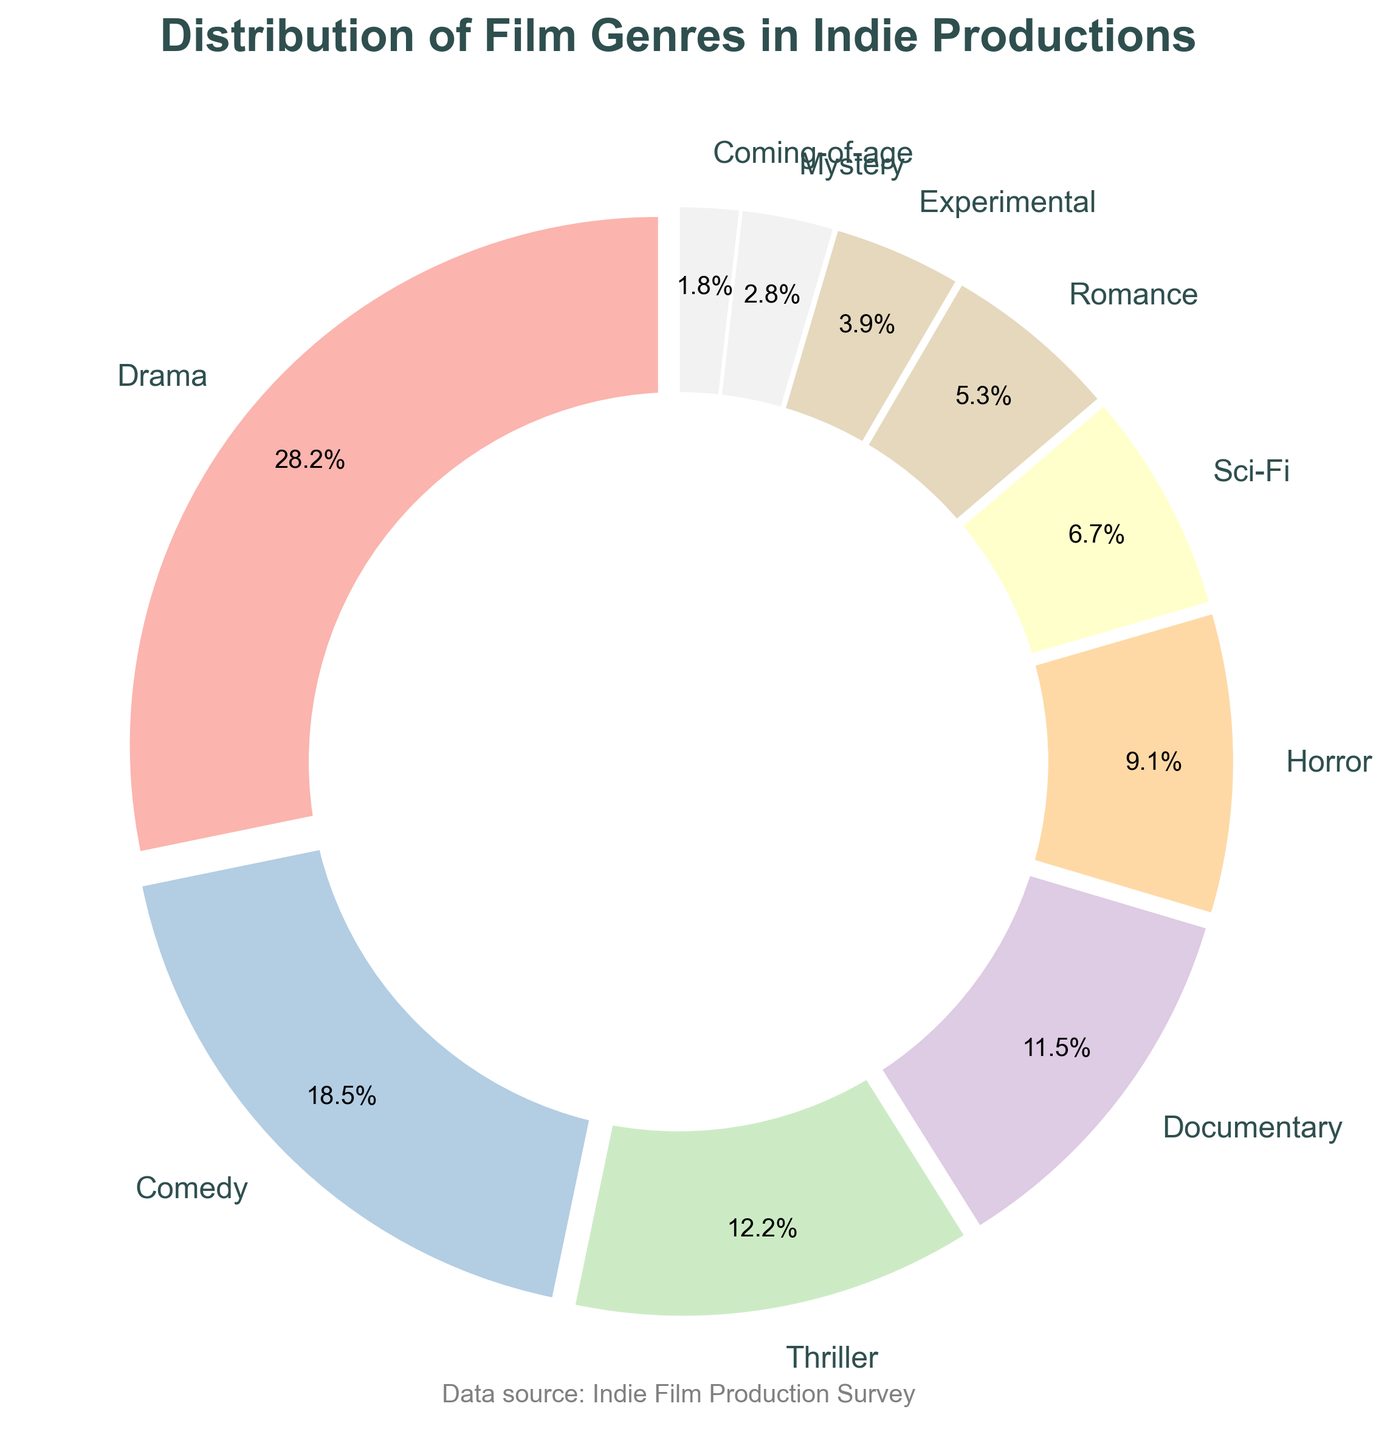What's the most common film genre in indie productions? The pie chart shows the distribution of film genres in indie productions. By looking at the pie segments, the largest segment represents Drama, with a percentage of 28.5%, making it the most common genre.
Answer: Drama Which genre has a slightly higher percentage than Horror? According to the pie chart, Documentary has a percentage of 11.6% which is slightly higher than Horror's 9.2%.
Answer: Documentary What is the combined percentage of Comedy and Thriller genres? From the pie chart, Comedy has a percentage of 18.7%, and Thriller has 12.3%. Adding these together, 18.7% + 12.3% = 31%.
Answer: 31% Is there a genre with less than 2% representation? If yes, which one? The pie chart shows Coming-of-age with a percentage of 1.8%, which is less than 2%.
Answer: Coming-of-age How many genres have a percentage greater than 10%? Observing the pie chart, Drama (28.5%), Comedy (18.7%), Thriller (12.3%), and Documentary (11.6%) each have percentages greater than 10%. There are four such genres.
Answer: Four Which genre's percentage is closest to the average percentage across all genres? To find the average, sum all percentages: 28.5 + 18.7 + 12.3 + 11.6 + 9.2 + 6.8 + 5.4 + 3.9 + 2.8 + 1.8 = 100%. The average is 100% ÷ 10 = 10%. The closest genre to this average is Documentary with 11.6%.
Answer: Documentary Is the percentage of Experimental higher or lower than Romance? According to the pie chart, Experimental has a percentage of 3.9%, whereas Romance has 5.4%. So, Experimental is lower than Romance.
Answer: Lower What is the discrepancy in percentage between the largest and smallest genre? From the chart, the largest genre is Drama with 28.5% and the smallest is Coming-of-age with 1.8%. The discrepancy is 28.5% - 1.8% = 26.7%.
Answer: 26.7% Does Sci-Fi or Mystery have a larger percentage, and by how much? The chart shows Sci-Fi at 6.8% and Mystery at 2.8%. The difference between them is 6.8% - 2.8% = 4%. Sci-Fi has a larger percentage, by 4%.
Answer: Sci-Fi, 4% 